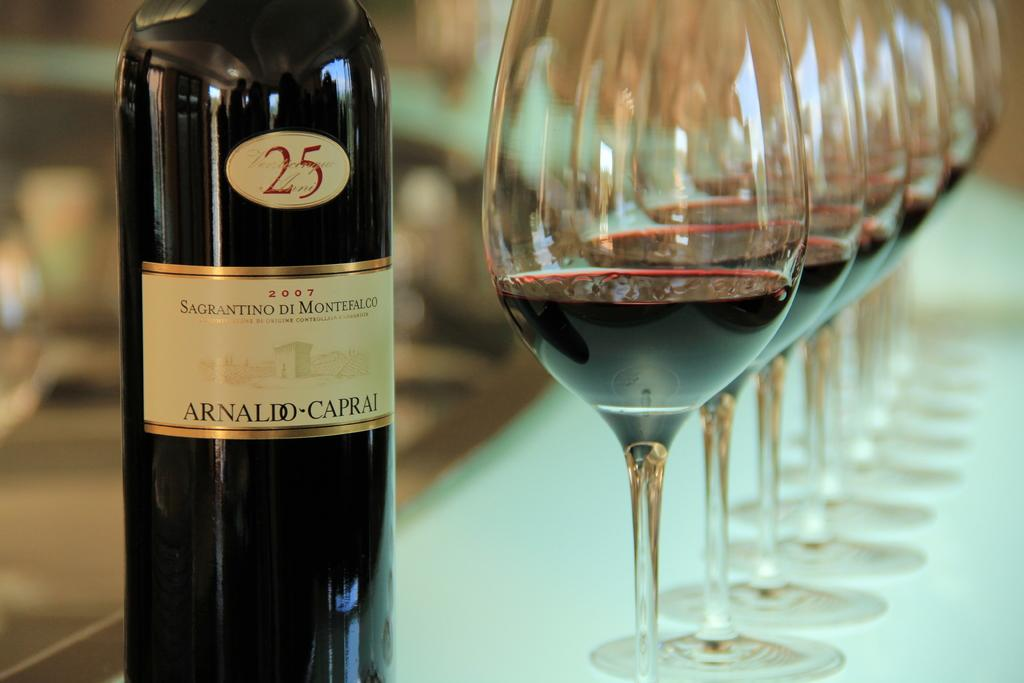<image>
Describe the image concisely. A bottle of Sagrantino Di Montefalco is standing near half empty glasses 